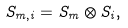Convert formula to latex. <formula><loc_0><loc_0><loc_500><loc_500>S _ { m , i } = S _ { m } \otimes S _ { i } ,</formula> 